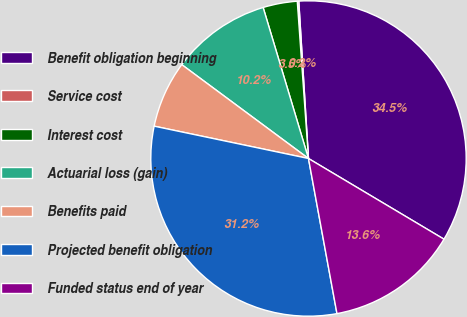Convert chart to OTSL. <chart><loc_0><loc_0><loc_500><loc_500><pie_chart><fcel>Benefit obligation beginning<fcel>Service cost<fcel>Interest cost<fcel>Actuarial loss (gain)<fcel>Benefits paid<fcel>Projected benefit obligation<fcel>Funded status end of year<nl><fcel>34.53%<fcel>0.15%<fcel>3.51%<fcel>10.21%<fcel>6.86%<fcel>31.18%<fcel>13.56%<nl></chart> 